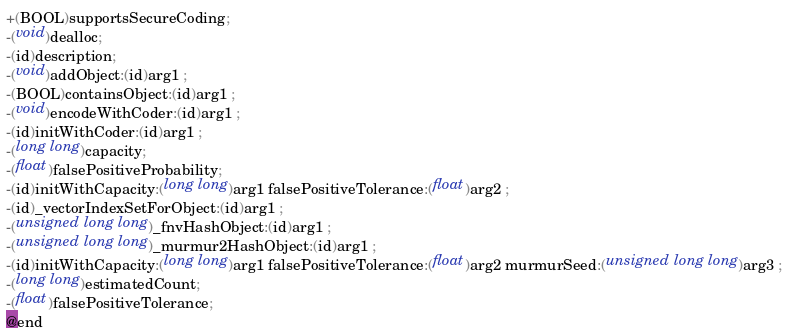Convert code to text. <code><loc_0><loc_0><loc_500><loc_500><_C_>+(BOOL)supportsSecureCoding;
-(void)dealloc;
-(id)description;
-(void)addObject:(id)arg1 ;
-(BOOL)containsObject:(id)arg1 ;
-(void)encodeWithCoder:(id)arg1 ;
-(id)initWithCoder:(id)arg1 ;
-(long long)capacity;
-(float)falsePositiveProbability;
-(id)initWithCapacity:(long long)arg1 falsePositiveTolerance:(float)arg2 ;
-(id)_vectorIndexSetForObject:(id)arg1 ;
-(unsigned long long)_fnvHashObject:(id)arg1 ;
-(unsigned long long)_murmur2HashObject:(id)arg1 ;
-(id)initWithCapacity:(long long)arg1 falsePositiveTolerance:(float)arg2 murmurSeed:(unsigned long long)arg3 ;
-(long long)estimatedCount;
-(float)falsePositiveTolerance;
@end

</code> 